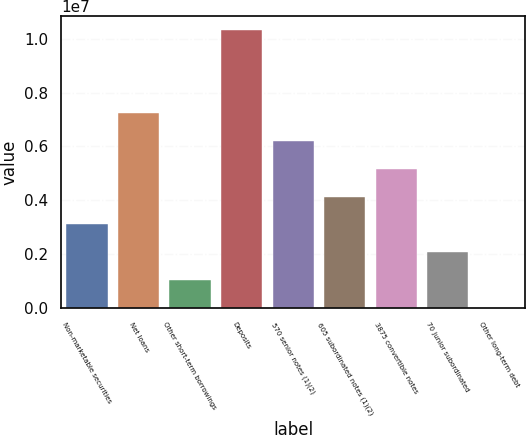Convert chart to OTSL. <chart><loc_0><loc_0><loc_500><loc_500><bar_chart><fcel>Non-marketable securities<fcel>Net loans<fcel>Other short-term borrowings<fcel>Deposits<fcel>570 senior notes (1)(2)<fcel>605 subordinated notes (1)(2)<fcel>3875 convertible notes<fcel>70 junior subordinated<fcel>Other long-term debt<nl><fcel>3.10455e+06<fcel>7.23417e+06<fcel>1.03974e+06<fcel>1.03314e+07<fcel>6.20176e+06<fcel>4.13696e+06<fcel>5.16936e+06<fcel>2.07215e+06<fcel>7339<nl></chart> 